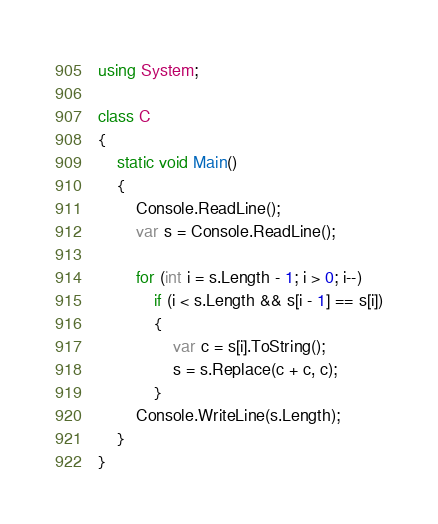<code> <loc_0><loc_0><loc_500><loc_500><_C#_>using System;

class C
{
	static void Main()
	{
		Console.ReadLine();
		var s = Console.ReadLine();

		for (int i = s.Length - 1; i > 0; i--)
			if (i < s.Length && s[i - 1] == s[i])
			{
				var c = s[i].ToString();
				s = s.Replace(c + c, c);
			}
		Console.WriteLine(s.Length);
	}
}
</code> 